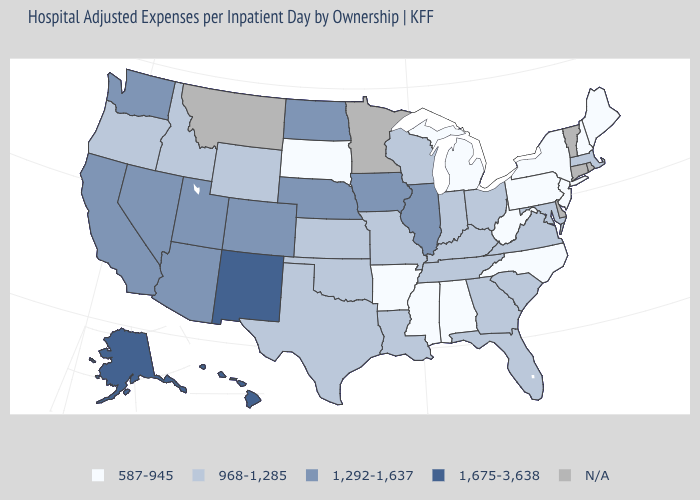What is the value of Delaware?
Give a very brief answer. N/A. What is the value of Pennsylvania?
Give a very brief answer. 587-945. What is the value of Alabama?
Keep it brief. 587-945. What is the value of Washington?
Keep it brief. 1,292-1,637. Does Missouri have the highest value in the MidWest?
Write a very short answer. No. What is the value of Alaska?
Quick response, please. 1,675-3,638. Name the states that have a value in the range 968-1,285?
Give a very brief answer. Florida, Georgia, Idaho, Indiana, Kansas, Kentucky, Louisiana, Maryland, Massachusetts, Missouri, Ohio, Oklahoma, Oregon, South Carolina, Tennessee, Texas, Virginia, Wisconsin, Wyoming. Is the legend a continuous bar?
Concise answer only. No. What is the value of Indiana?
Keep it brief. 968-1,285. What is the value of North Carolina?
Be succinct. 587-945. What is the highest value in the USA?
Be succinct. 1,675-3,638. Does Wisconsin have the lowest value in the USA?
Keep it brief. No. What is the value of Kentucky?
Concise answer only. 968-1,285. What is the value of Alaska?
Be succinct. 1,675-3,638. Which states hav the highest value in the Northeast?
Keep it brief. Massachusetts. 